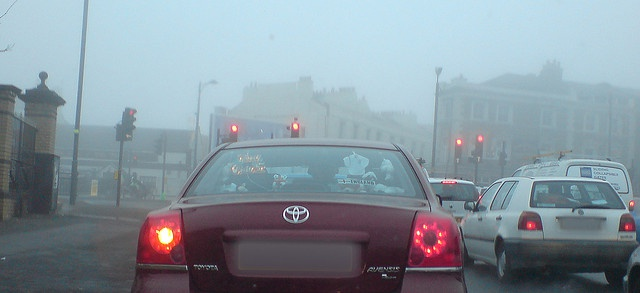Describe the objects in this image and their specific colors. I can see car in lightblue, gray, black, and darkgray tones, car in lightblue, gray, black, and darkgray tones, car in lightblue, darkgray, and gray tones, car in lightblue, gray, and darkgray tones, and traffic light in lightblue, gray, and lightpink tones in this image. 